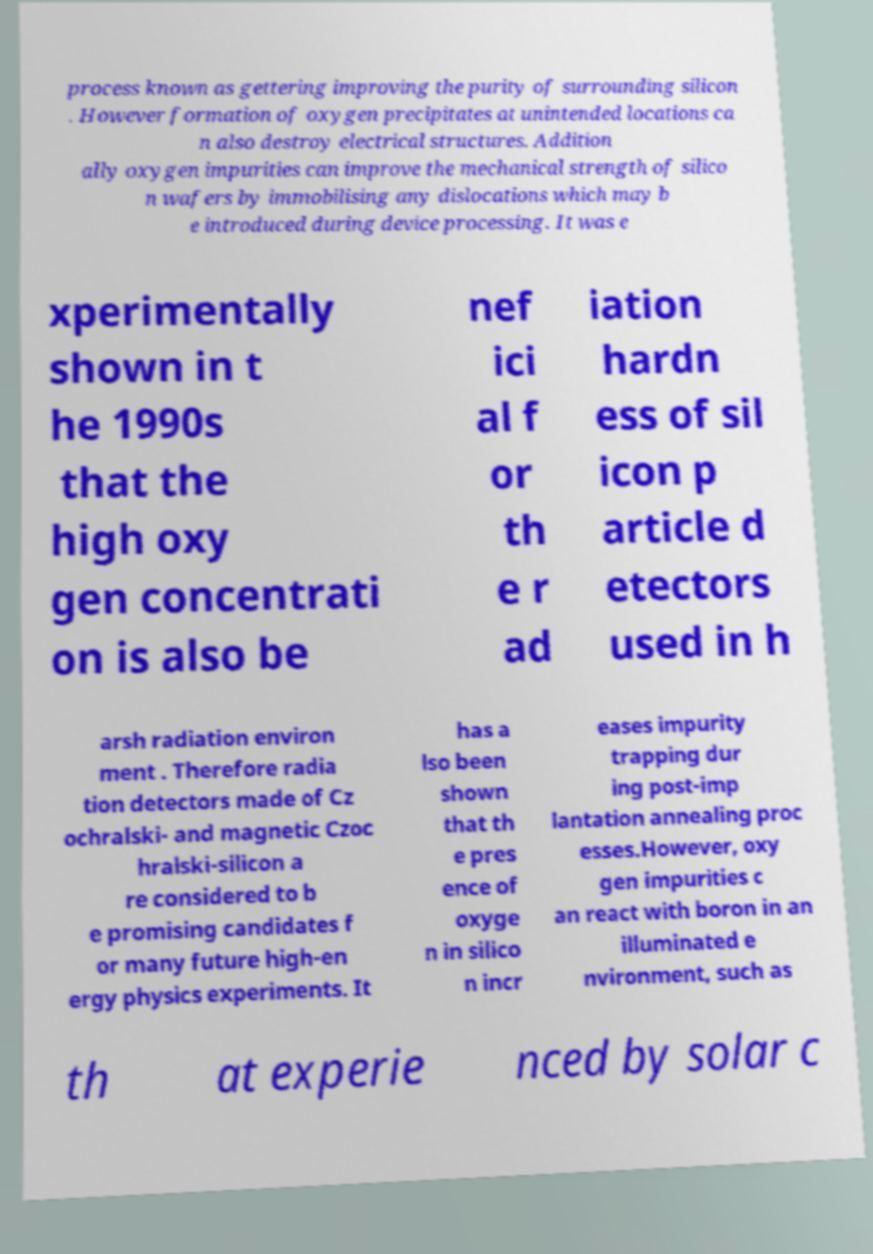Could you extract and type out the text from this image? process known as gettering improving the purity of surrounding silicon . However formation of oxygen precipitates at unintended locations ca n also destroy electrical structures. Addition ally oxygen impurities can improve the mechanical strength of silico n wafers by immobilising any dislocations which may b e introduced during device processing. It was e xperimentally shown in t he 1990s that the high oxy gen concentrati on is also be nef ici al f or th e r ad iation hardn ess of sil icon p article d etectors used in h arsh radiation environ ment . Therefore radia tion detectors made of Cz ochralski- and magnetic Czoc hralski-silicon a re considered to b e promising candidates f or many future high-en ergy physics experiments. It has a lso been shown that th e pres ence of oxyge n in silico n incr eases impurity trapping dur ing post-imp lantation annealing proc esses.However, oxy gen impurities c an react with boron in an illuminated e nvironment, such as th at experie nced by solar c 